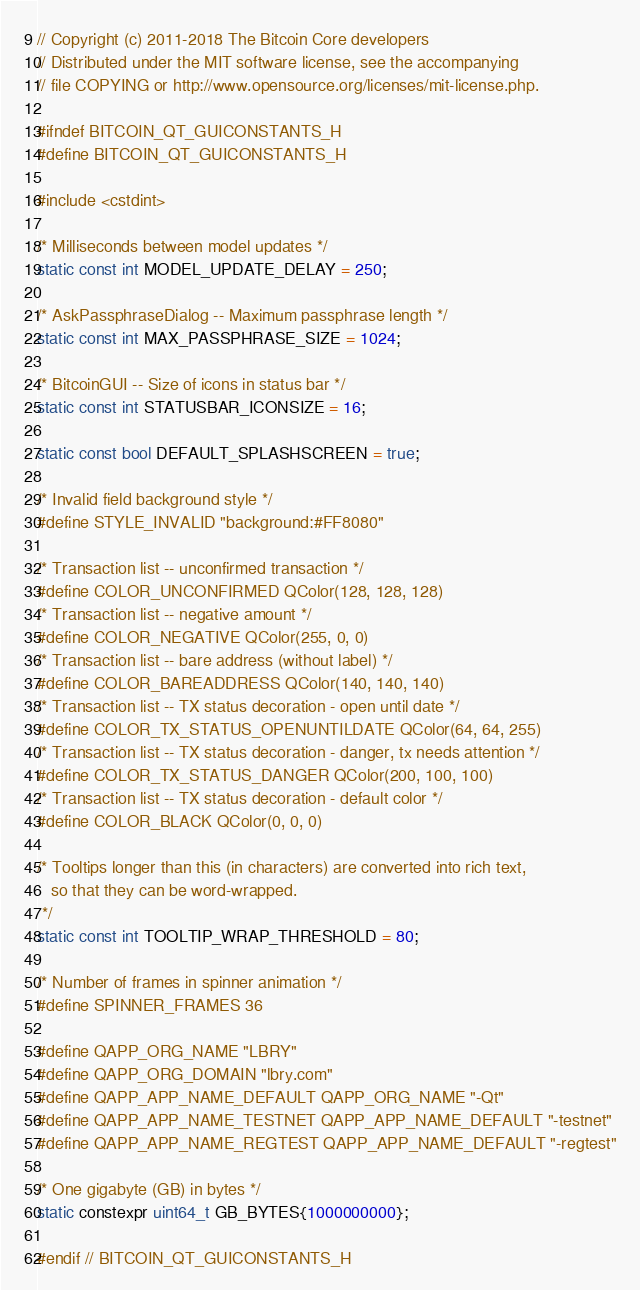Convert code to text. <code><loc_0><loc_0><loc_500><loc_500><_C_>// Copyright (c) 2011-2018 The Bitcoin Core developers
// Distributed under the MIT software license, see the accompanying
// file COPYING or http://www.opensource.org/licenses/mit-license.php.

#ifndef BITCOIN_QT_GUICONSTANTS_H
#define BITCOIN_QT_GUICONSTANTS_H

#include <cstdint>

/* Milliseconds between model updates */
static const int MODEL_UPDATE_DELAY = 250;

/* AskPassphraseDialog -- Maximum passphrase length */
static const int MAX_PASSPHRASE_SIZE = 1024;

/* BitcoinGUI -- Size of icons in status bar */
static const int STATUSBAR_ICONSIZE = 16;

static const bool DEFAULT_SPLASHSCREEN = true;

/* Invalid field background style */
#define STYLE_INVALID "background:#FF8080"

/* Transaction list -- unconfirmed transaction */
#define COLOR_UNCONFIRMED QColor(128, 128, 128)
/* Transaction list -- negative amount */
#define COLOR_NEGATIVE QColor(255, 0, 0)
/* Transaction list -- bare address (without label) */
#define COLOR_BAREADDRESS QColor(140, 140, 140)
/* Transaction list -- TX status decoration - open until date */
#define COLOR_TX_STATUS_OPENUNTILDATE QColor(64, 64, 255)
/* Transaction list -- TX status decoration - danger, tx needs attention */
#define COLOR_TX_STATUS_DANGER QColor(200, 100, 100)
/* Transaction list -- TX status decoration - default color */
#define COLOR_BLACK QColor(0, 0, 0)

/* Tooltips longer than this (in characters) are converted into rich text,
   so that they can be word-wrapped.
 */
static const int TOOLTIP_WRAP_THRESHOLD = 80;

/* Number of frames in spinner animation */
#define SPINNER_FRAMES 36

#define QAPP_ORG_NAME "LBRY"
#define QAPP_ORG_DOMAIN "lbry.com"
#define QAPP_APP_NAME_DEFAULT QAPP_ORG_NAME "-Qt"
#define QAPP_APP_NAME_TESTNET QAPP_APP_NAME_DEFAULT "-testnet"
#define QAPP_APP_NAME_REGTEST QAPP_APP_NAME_DEFAULT "-regtest"

/* One gigabyte (GB) in bytes */
static constexpr uint64_t GB_BYTES{1000000000};

#endif // BITCOIN_QT_GUICONSTANTS_H
</code> 